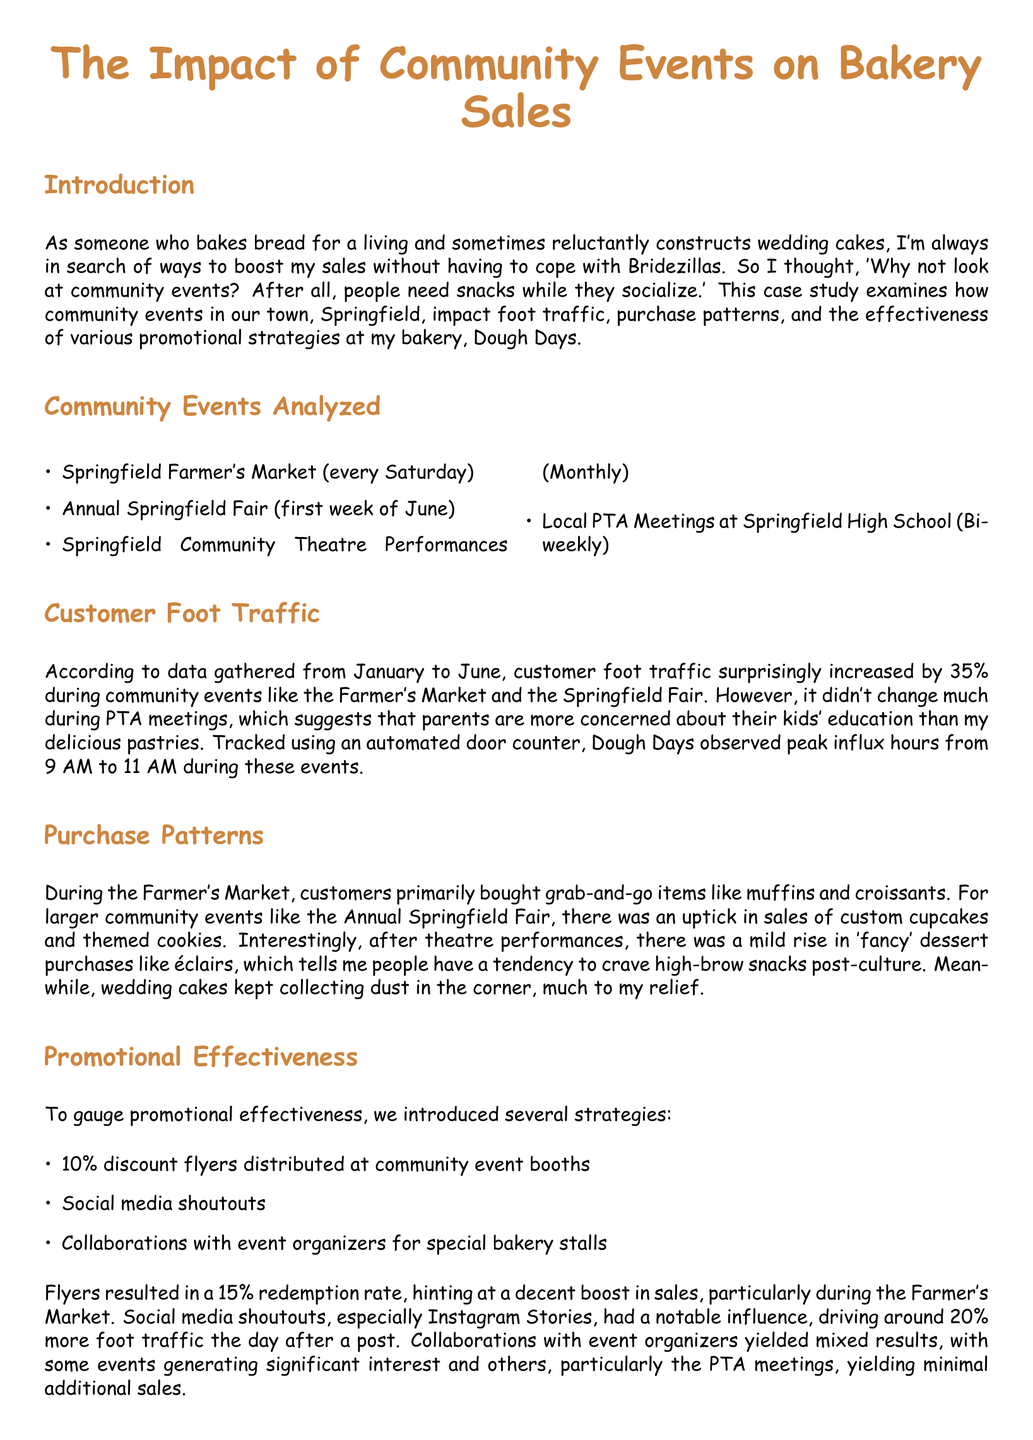what was the increase in customer foot traffic during community events? The document states that customer foot traffic increased by 35% during community events.
Answer: 35% which community event is held monthly? The document lists the Springfield Community Theatre Performances as a monthly event.
Answer: Monthly what items did customers primarily buy during the Farmer's Market? The case study mentions that customers primarily bought grab-and-go items like muffins and croissants during the Farmer's Market.
Answer: muffins and croissants what was the redemption rate of the flyers? The document indicates that the redemption rate of the flyers was 15%.
Answer: 15% which promotional tactic had a notable influence on foot traffic? The case study highlights that social media shoutouts, especially Instagram Stories, had a notable influence on foot traffic.
Answer: social media shoutouts how much more foot traffic was driven by social media shoutouts the day after a post? It states that social media shoutouts drove around 20% more foot traffic the day after a post.
Answer: 20% what is the impact of the Annual Springfield Fair on cupcake sales? The document mentions that there was an uptick in sales of custom cupcakes during the Annual Springfield Fair.
Answer: uptick how do customers feel after theatre performances according to the study? The case study suggests that people tend to crave high-brow snacks like éclairs post-culture after theatre performances.
Answer: crave high-brow snacks what type of events require more innovative promotional strategies? According to the conclusion, PTA meetings require more innovative promotional strategies to improve their impact on sales.
Answer: PTA meetings 